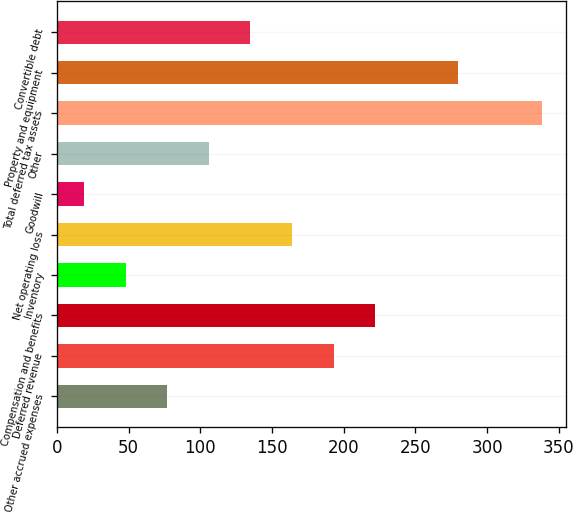Convert chart to OTSL. <chart><loc_0><loc_0><loc_500><loc_500><bar_chart><fcel>Other accrued expenses<fcel>Deferred revenue<fcel>Compensation and benefits<fcel>Inventory<fcel>Net operating loss<fcel>Goodwill<fcel>Other<fcel>Total deferred tax assets<fcel>Property and equipment<fcel>Convertible debt<nl><fcel>77<fcel>193<fcel>222<fcel>48<fcel>164<fcel>19<fcel>106<fcel>338<fcel>280<fcel>135<nl></chart> 